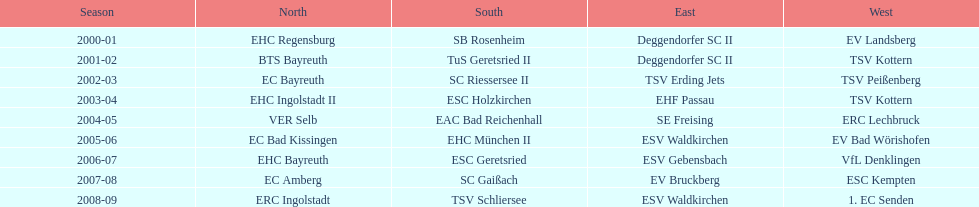Can you parse all the data within this table? {'header': ['Season', 'North', 'South', 'East', 'West'], 'rows': [['2000-01', 'EHC Regensburg', 'SB Rosenheim', 'Deggendorfer SC II', 'EV Landsberg'], ['2001-02', 'BTS Bayreuth', 'TuS Geretsried II', 'Deggendorfer SC II', 'TSV Kottern'], ['2002-03', 'EC Bayreuth', 'SC Riessersee II', 'TSV Erding Jets', 'TSV Peißenberg'], ['2003-04', 'EHC Ingolstadt II', 'ESC Holzkirchen', 'EHF Passau', 'TSV Kottern'], ['2004-05', 'VER Selb', 'EAC Bad Reichenhall', 'SE Freising', 'ERC Lechbruck'], ['2005-06', 'EC Bad Kissingen', 'EHC München II', 'ESV Waldkirchen', 'EV Bad Wörishofen'], ['2006-07', 'EHC Bayreuth', 'ESC Geretsried', 'ESV Gebensbach', 'VfL Denklingen'], ['2007-08', 'EC Amberg', 'SC Gaißach', 'EV Bruckberg', 'ESC Kempten'], ['2008-09', 'ERC Ingolstadt', 'TSV Schliersee', 'ESV Waldkirchen', '1. EC Senden']]} Who won the south after esc geretsried did during the 2006-07 season? SC Gaißach. 